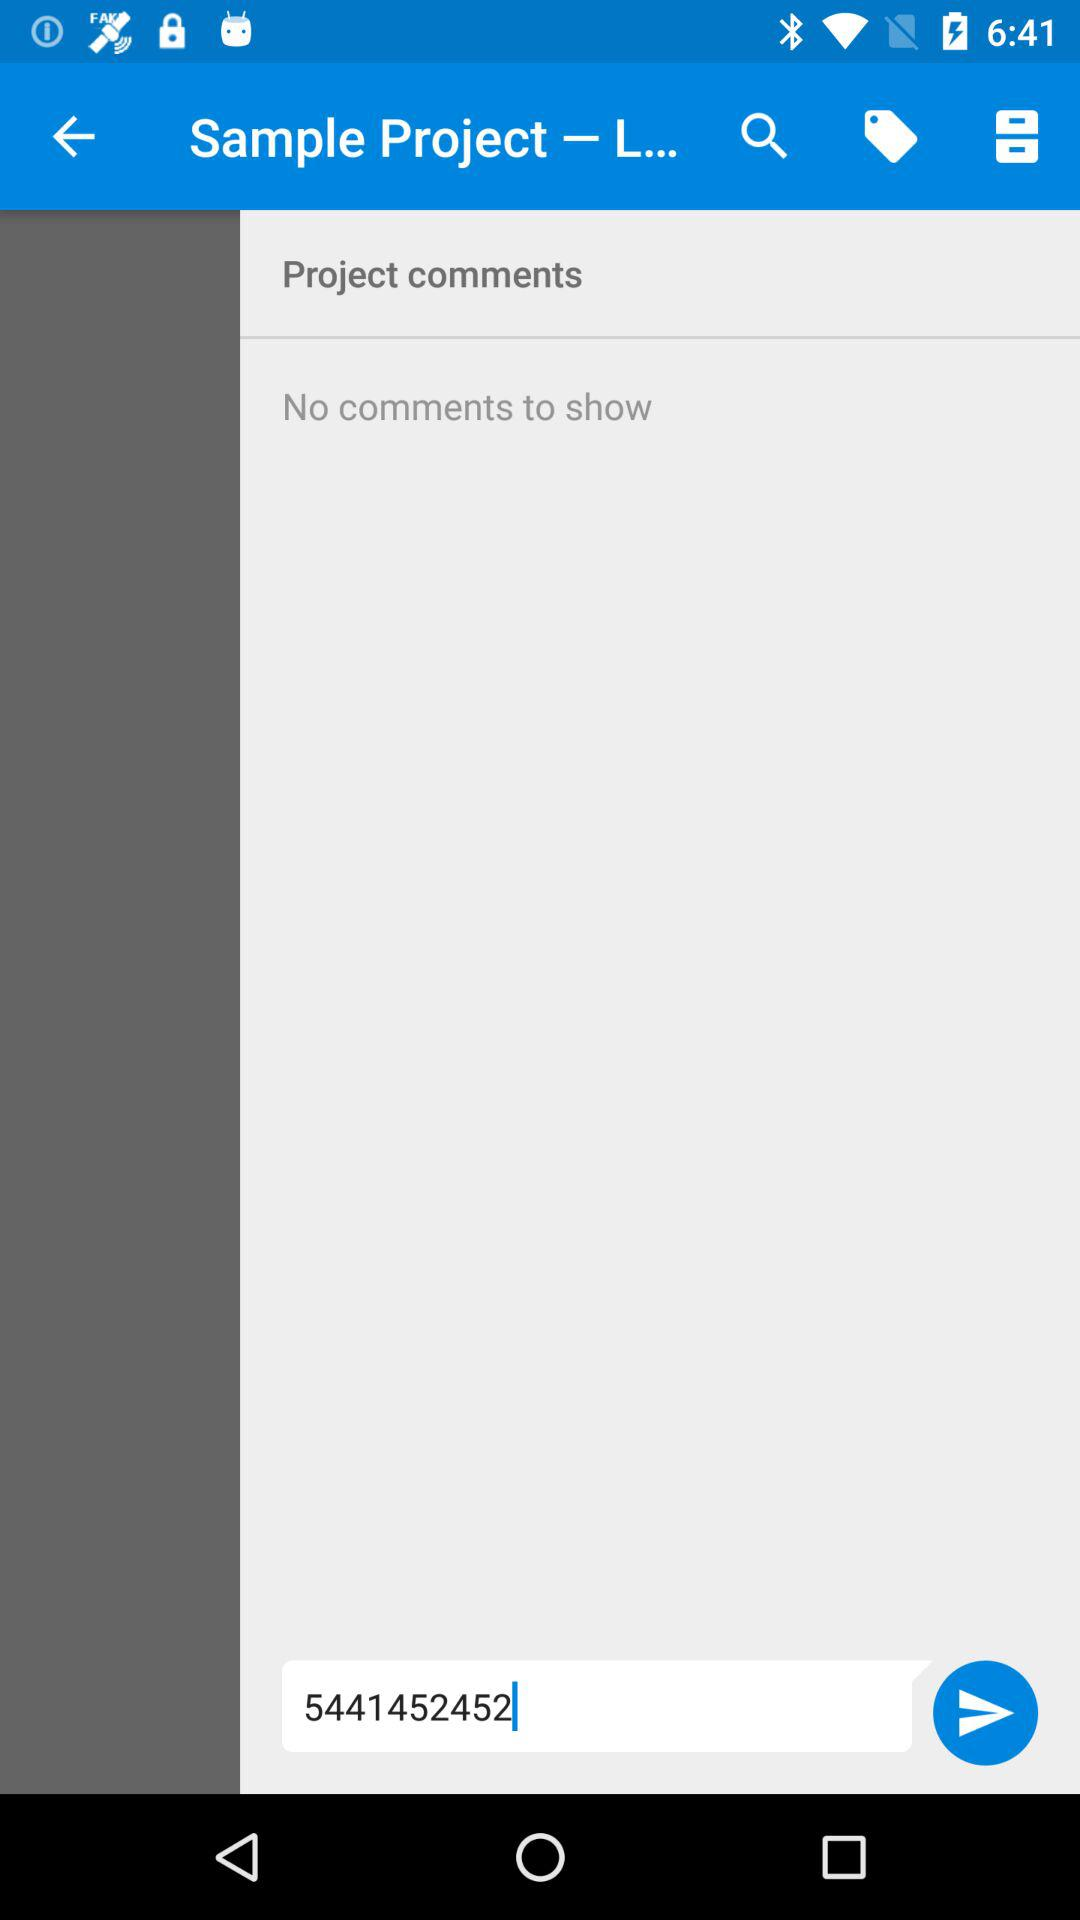Is there any comment shown on the screen? There is no comment shown on the screen. 